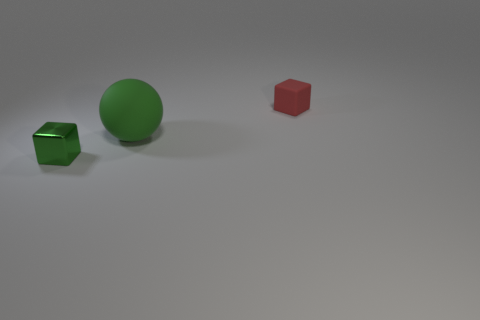Add 2 metal objects. How many objects exist? 5 Subtract all cubes. How many objects are left? 1 Subtract 0 purple blocks. How many objects are left? 3 Subtract all large balls. Subtract all green blocks. How many objects are left? 1 Add 1 small red objects. How many small red objects are left? 2 Add 3 tiny green metallic cubes. How many tiny green metallic cubes exist? 4 